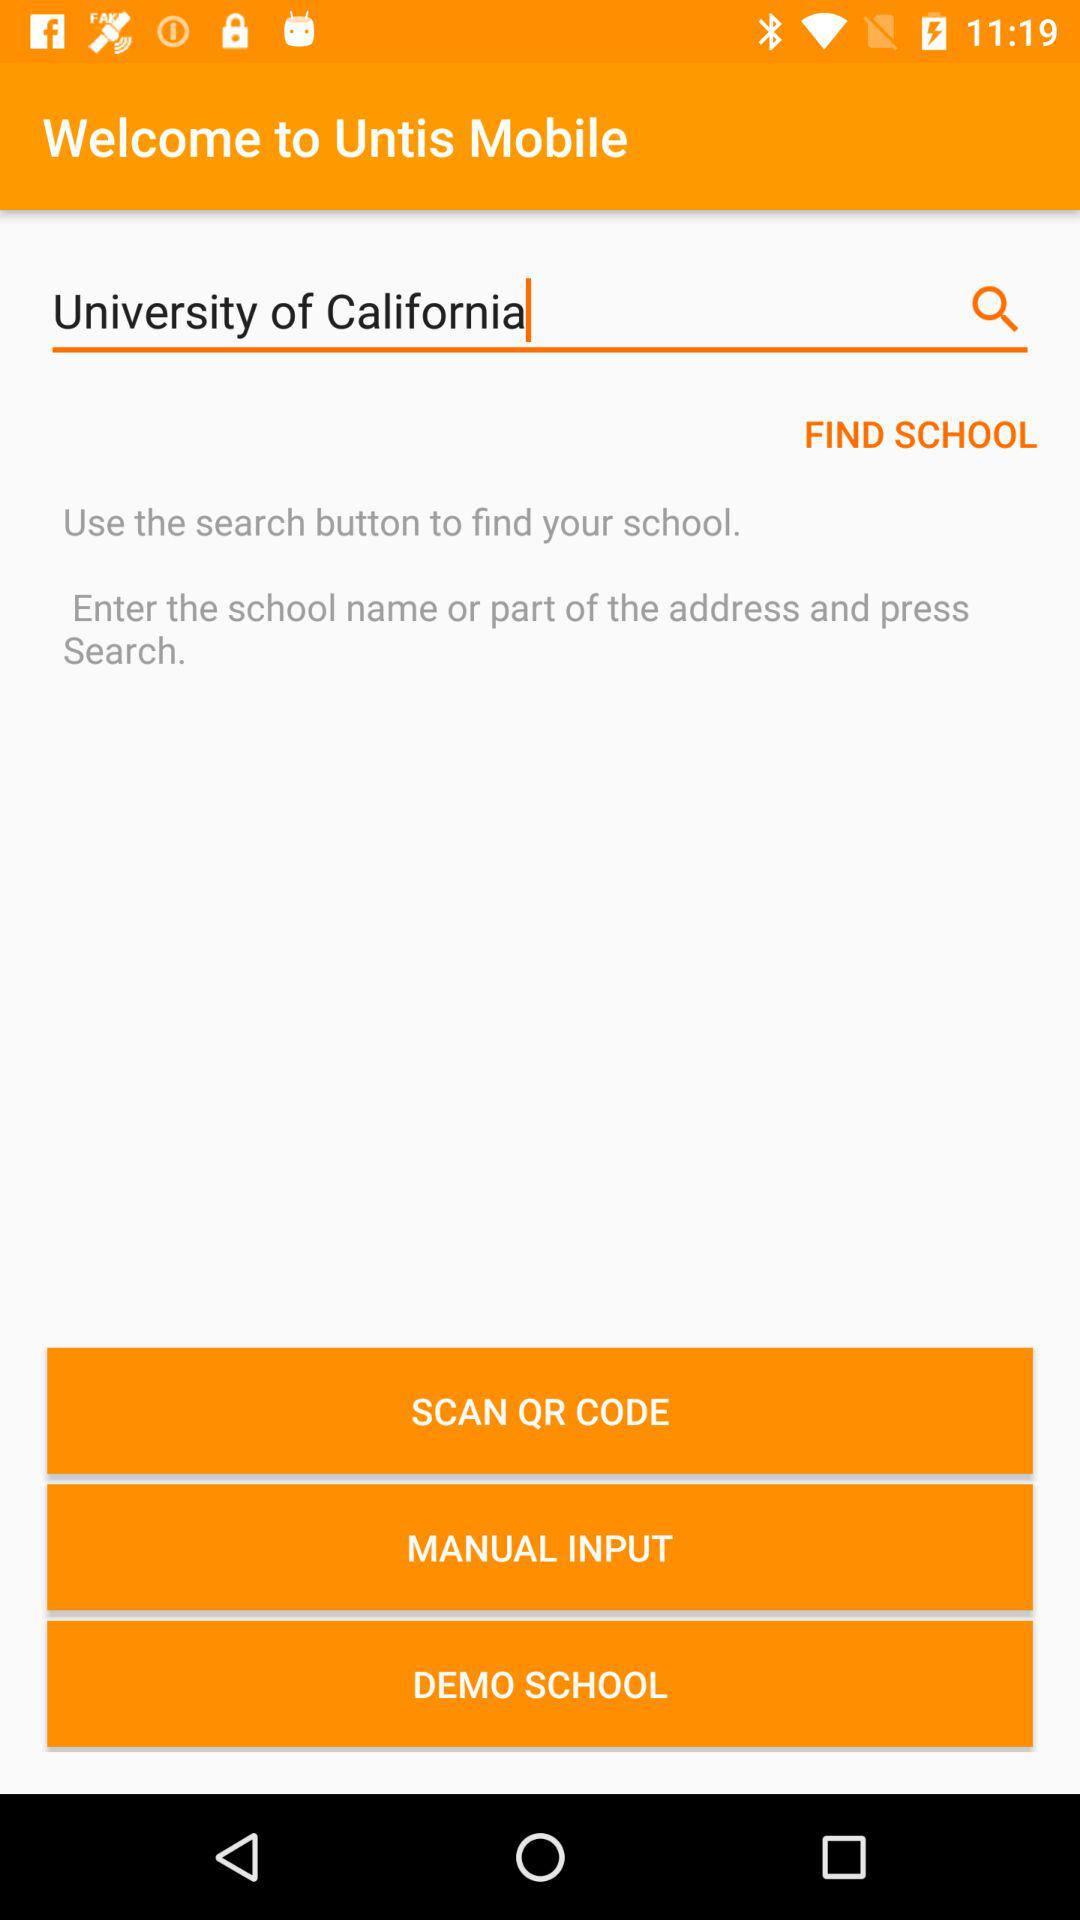What university name is entered in the search bar? The entered university name is University of California. 